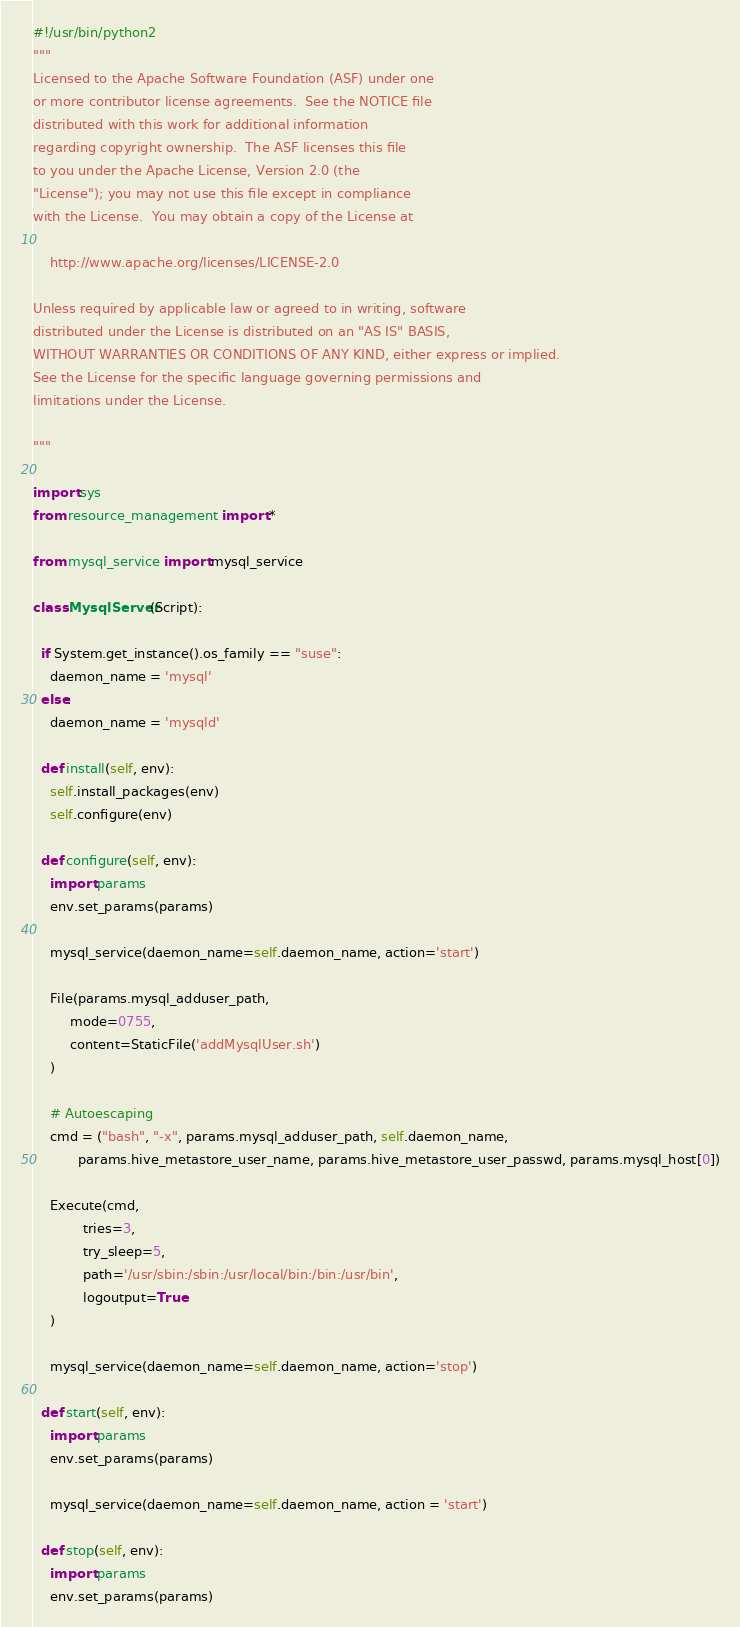<code> <loc_0><loc_0><loc_500><loc_500><_Python_>#!/usr/bin/python2
"""
Licensed to the Apache Software Foundation (ASF) under one
or more contributor license agreements.  See the NOTICE file
distributed with this work for additional information
regarding copyright ownership.  The ASF licenses this file
to you under the Apache License, Version 2.0 (the
"License"); you may not use this file except in compliance
with the License.  You may obtain a copy of the License at

    http://www.apache.org/licenses/LICENSE-2.0

Unless required by applicable law or agreed to in writing, software
distributed under the License is distributed on an "AS IS" BASIS,
WITHOUT WARRANTIES OR CONDITIONS OF ANY KIND, either express or implied.
See the License for the specific language governing permissions and
limitations under the License.

"""

import sys
from resource_management import *

from mysql_service import mysql_service

class MysqlServer(Script):

  if System.get_instance().os_family == "suse":
    daemon_name = 'mysql'
  else:
    daemon_name = 'mysqld'

  def install(self, env):
    self.install_packages(env)
    self.configure(env)

  def configure(self, env):
    import params
    env.set_params(params)

    mysql_service(daemon_name=self.daemon_name, action='start')

    File(params.mysql_adduser_path,
         mode=0755,
         content=StaticFile('addMysqlUser.sh')
    )

    # Autoescaping
    cmd = ("bash", "-x", params.mysql_adduser_path, self.daemon_name,
           params.hive_metastore_user_name, params.hive_metastore_user_passwd, params.mysql_host[0])

    Execute(cmd,
            tries=3,
            try_sleep=5,
            path='/usr/sbin:/sbin:/usr/local/bin:/bin:/usr/bin',
            logoutput=True
    )

    mysql_service(daemon_name=self.daemon_name, action='stop')

  def start(self, env):
    import params
    env.set_params(params)

    mysql_service(daemon_name=self.daemon_name, action = 'start')

  def stop(self, env):
    import params
    env.set_params(params)
</code> 